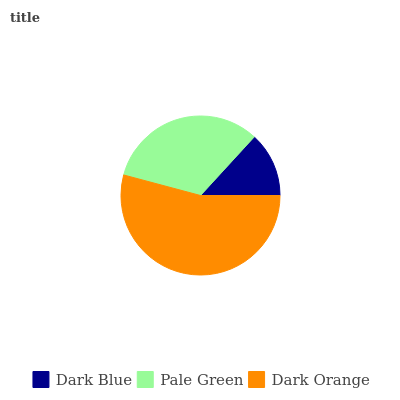Is Dark Blue the minimum?
Answer yes or no. Yes. Is Dark Orange the maximum?
Answer yes or no. Yes. Is Pale Green the minimum?
Answer yes or no. No. Is Pale Green the maximum?
Answer yes or no. No. Is Pale Green greater than Dark Blue?
Answer yes or no. Yes. Is Dark Blue less than Pale Green?
Answer yes or no. Yes. Is Dark Blue greater than Pale Green?
Answer yes or no. No. Is Pale Green less than Dark Blue?
Answer yes or no. No. Is Pale Green the high median?
Answer yes or no. Yes. Is Pale Green the low median?
Answer yes or no. Yes. Is Dark Orange the high median?
Answer yes or no. No. Is Dark Orange the low median?
Answer yes or no. No. 